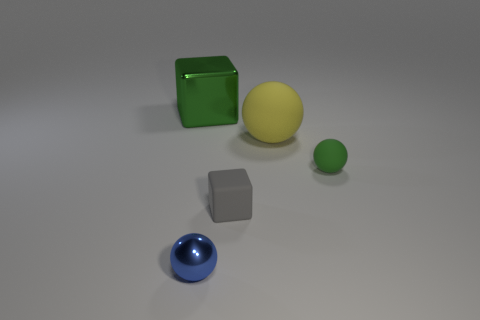Add 3 blue cubes. How many objects exist? 8 Subtract all rubber spheres. How many spheres are left? 1 Subtract all balls. How many objects are left? 2 Subtract 1 balls. How many balls are left? 2 Add 3 big rubber things. How many big rubber things exist? 4 Subtract all gray cubes. How many cubes are left? 1 Subtract 0 blue cylinders. How many objects are left? 5 Subtract all gray blocks. Subtract all green cylinders. How many blocks are left? 1 Subtract all big spheres. Subtract all yellow rubber spheres. How many objects are left? 3 Add 3 yellow matte balls. How many yellow matte balls are left? 4 